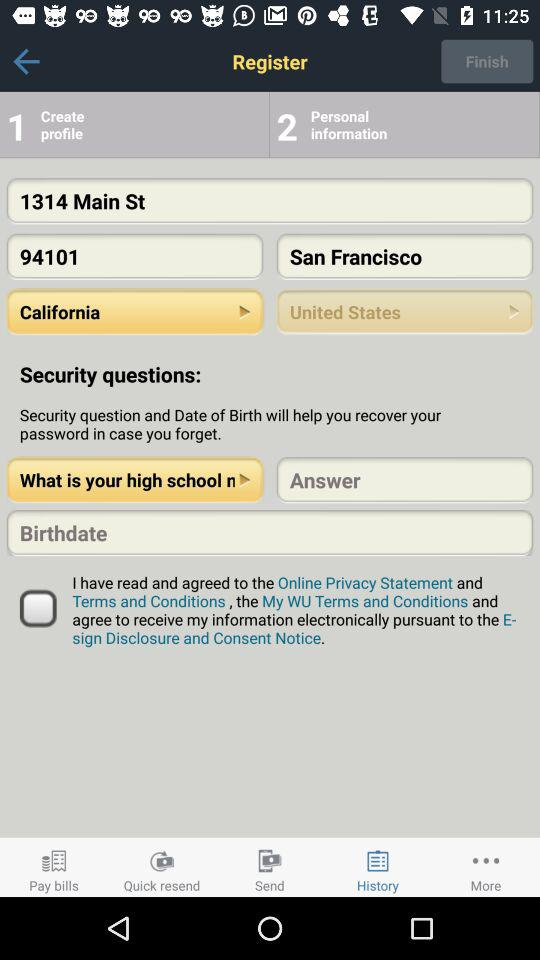Define selected question?
When the provided information is insufficient, respond with <no answer>. <no answer> 